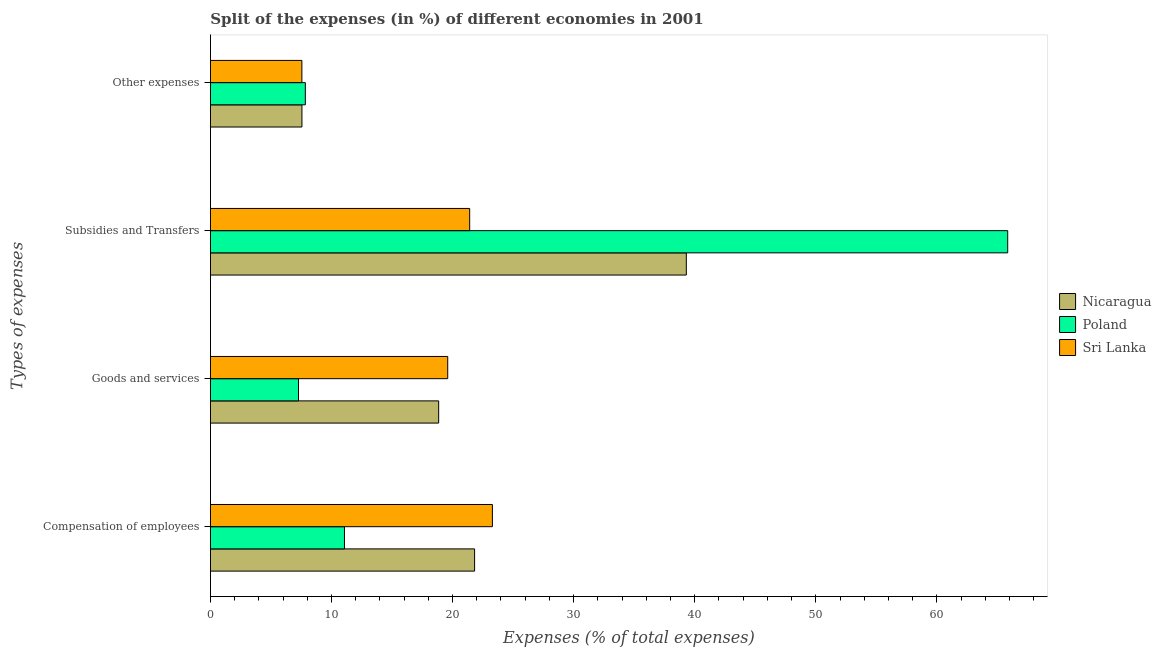How many different coloured bars are there?
Ensure brevity in your answer.  3. How many groups of bars are there?
Your answer should be compact. 4. Are the number of bars on each tick of the Y-axis equal?
Offer a terse response. Yes. What is the label of the 3rd group of bars from the top?
Give a very brief answer. Goods and services. What is the percentage of amount spent on compensation of employees in Nicaragua?
Your response must be concise. 21.82. Across all countries, what is the maximum percentage of amount spent on compensation of employees?
Your answer should be very brief. 23.29. Across all countries, what is the minimum percentage of amount spent on subsidies?
Offer a very short reply. 21.41. In which country was the percentage of amount spent on other expenses minimum?
Your answer should be very brief. Sri Lanka. What is the total percentage of amount spent on subsidies in the graph?
Give a very brief answer. 126.57. What is the difference between the percentage of amount spent on other expenses in Nicaragua and that in Poland?
Offer a terse response. -0.28. What is the difference between the percentage of amount spent on subsidies in Poland and the percentage of amount spent on goods and services in Nicaragua?
Provide a short and direct response. 47. What is the average percentage of amount spent on subsidies per country?
Provide a short and direct response. 42.19. What is the difference between the percentage of amount spent on goods and services and percentage of amount spent on other expenses in Nicaragua?
Keep it short and to the point. 11.29. What is the ratio of the percentage of amount spent on goods and services in Sri Lanka to that in Nicaragua?
Make the answer very short. 1.04. Is the percentage of amount spent on other expenses in Sri Lanka less than that in Nicaragua?
Your response must be concise. Yes. Is the difference between the percentage of amount spent on compensation of employees in Nicaragua and Poland greater than the difference between the percentage of amount spent on subsidies in Nicaragua and Poland?
Provide a short and direct response. Yes. What is the difference between the highest and the second highest percentage of amount spent on goods and services?
Your response must be concise. 0.75. What is the difference between the highest and the lowest percentage of amount spent on goods and services?
Ensure brevity in your answer.  12.32. Is the sum of the percentage of amount spent on subsidies in Sri Lanka and Poland greater than the maximum percentage of amount spent on compensation of employees across all countries?
Your response must be concise. Yes. Is it the case that in every country, the sum of the percentage of amount spent on goods and services and percentage of amount spent on compensation of employees is greater than the sum of percentage of amount spent on subsidies and percentage of amount spent on other expenses?
Your answer should be very brief. No. How many bars are there?
Your answer should be compact. 12. Are all the bars in the graph horizontal?
Provide a succinct answer. Yes. How many countries are there in the graph?
Your response must be concise. 3. Are the values on the major ticks of X-axis written in scientific E-notation?
Your answer should be very brief. No. Does the graph contain any zero values?
Offer a terse response. No. How many legend labels are there?
Ensure brevity in your answer.  3. How are the legend labels stacked?
Your answer should be very brief. Vertical. What is the title of the graph?
Provide a succinct answer. Split of the expenses (in %) of different economies in 2001. Does "Chad" appear as one of the legend labels in the graph?
Ensure brevity in your answer.  No. What is the label or title of the X-axis?
Your response must be concise. Expenses (% of total expenses). What is the label or title of the Y-axis?
Give a very brief answer. Types of expenses. What is the Expenses (% of total expenses) in Nicaragua in Compensation of employees?
Ensure brevity in your answer.  21.82. What is the Expenses (% of total expenses) of Poland in Compensation of employees?
Give a very brief answer. 11.07. What is the Expenses (% of total expenses) of Sri Lanka in Compensation of employees?
Give a very brief answer. 23.29. What is the Expenses (% of total expenses) in Nicaragua in Goods and services?
Provide a succinct answer. 18.85. What is the Expenses (% of total expenses) of Poland in Goods and services?
Make the answer very short. 7.28. What is the Expenses (% of total expenses) of Sri Lanka in Goods and services?
Provide a short and direct response. 19.6. What is the Expenses (% of total expenses) of Nicaragua in Subsidies and Transfers?
Give a very brief answer. 39.31. What is the Expenses (% of total expenses) of Poland in Subsidies and Transfers?
Keep it short and to the point. 65.85. What is the Expenses (% of total expenses) in Sri Lanka in Subsidies and Transfers?
Provide a short and direct response. 21.41. What is the Expenses (% of total expenses) of Nicaragua in Other expenses?
Provide a short and direct response. 7.56. What is the Expenses (% of total expenses) of Poland in Other expenses?
Give a very brief answer. 7.84. What is the Expenses (% of total expenses) in Sri Lanka in Other expenses?
Your answer should be compact. 7.56. Across all Types of expenses, what is the maximum Expenses (% of total expenses) of Nicaragua?
Ensure brevity in your answer.  39.31. Across all Types of expenses, what is the maximum Expenses (% of total expenses) in Poland?
Provide a succinct answer. 65.85. Across all Types of expenses, what is the maximum Expenses (% of total expenses) in Sri Lanka?
Ensure brevity in your answer.  23.29. Across all Types of expenses, what is the minimum Expenses (% of total expenses) in Nicaragua?
Your response must be concise. 7.56. Across all Types of expenses, what is the minimum Expenses (% of total expenses) of Poland?
Your answer should be very brief. 7.28. Across all Types of expenses, what is the minimum Expenses (% of total expenses) in Sri Lanka?
Offer a terse response. 7.56. What is the total Expenses (% of total expenses) of Nicaragua in the graph?
Provide a short and direct response. 87.54. What is the total Expenses (% of total expenses) in Poland in the graph?
Offer a terse response. 92.04. What is the total Expenses (% of total expenses) of Sri Lanka in the graph?
Keep it short and to the point. 71.86. What is the difference between the Expenses (% of total expenses) of Nicaragua in Compensation of employees and that in Goods and services?
Your response must be concise. 2.97. What is the difference between the Expenses (% of total expenses) in Poland in Compensation of employees and that in Goods and services?
Your answer should be very brief. 3.8. What is the difference between the Expenses (% of total expenses) of Sri Lanka in Compensation of employees and that in Goods and services?
Give a very brief answer. 3.69. What is the difference between the Expenses (% of total expenses) of Nicaragua in Compensation of employees and that in Subsidies and Transfers?
Give a very brief answer. -17.49. What is the difference between the Expenses (% of total expenses) in Poland in Compensation of employees and that in Subsidies and Transfers?
Give a very brief answer. -54.78. What is the difference between the Expenses (% of total expenses) of Sri Lanka in Compensation of employees and that in Subsidies and Transfers?
Offer a very short reply. 1.88. What is the difference between the Expenses (% of total expenses) in Nicaragua in Compensation of employees and that in Other expenses?
Ensure brevity in your answer.  14.26. What is the difference between the Expenses (% of total expenses) in Poland in Compensation of employees and that in Other expenses?
Provide a succinct answer. 3.23. What is the difference between the Expenses (% of total expenses) of Sri Lanka in Compensation of employees and that in Other expenses?
Make the answer very short. 15.73. What is the difference between the Expenses (% of total expenses) of Nicaragua in Goods and services and that in Subsidies and Transfers?
Provide a short and direct response. -20.45. What is the difference between the Expenses (% of total expenses) in Poland in Goods and services and that in Subsidies and Transfers?
Provide a succinct answer. -58.57. What is the difference between the Expenses (% of total expenses) of Sri Lanka in Goods and services and that in Subsidies and Transfers?
Ensure brevity in your answer.  -1.81. What is the difference between the Expenses (% of total expenses) of Nicaragua in Goods and services and that in Other expenses?
Your answer should be compact. 11.29. What is the difference between the Expenses (% of total expenses) in Poland in Goods and services and that in Other expenses?
Offer a very short reply. -0.56. What is the difference between the Expenses (% of total expenses) in Sri Lanka in Goods and services and that in Other expenses?
Keep it short and to the point. 12.04. What is the difference between the Expenses (% of total expenses) of Nicaragua in Subsidies and Transfers and that in Other expenses?
Provide a succinct answer. 31.75. What is the difference between the Expenses (% of total expenses) in Poland in Subsidies and Transfers and that in Other expenses?
Keep it short and to the point. 58.01. What is the difference between the Expenses (% of total expenses) in Sri Lanka in Subsidies and Transfers and that in Other expenses?
Make the answer very short. 13.86. What is the difference between the Expenses (% of total expenses) in Nicaragua in Compensation of employees and the Expenses (% of total expenses) in Poland in Goods and services?
Provide a short and direct response. 14.54. What is the difference between the Expenses (% of total expenses) in Nicaragua in Compensation of employees and the Expenses (% of total expenses) in Sri Lanka in Goods and services?
Your answer should be very brief. 2.22. What is the difference between the Expenses (% of total expenses) of Poland in Compensation of employees and the Expenses (% of total expenses) of Sri Lanka in Goods and services?
Your response must be concise. -8.53. What is the difference between the Expenses (% of total expenses) of Nicaragua in Compensation of employees and the Expenses (% of total expenses) of Poland in Subsidies and Transfers?
Offer a very short reply. -44.03. What is the difference between the Expenses (% of total expenses) of Nicaragua in Compensation of employees and the Expenses (% of total expenses) of Sri Lanka in Subsidies and Transfers?
Offer a terse response. 0.41. What is the difference between the Expenses (% of total expenses) in Poland in Compensation of employees and the Expenses (% of total expenses) in Sri Lanka in Subsidies and Transfers?
Ensure brevity in your answer.  -10.34. What is the difference between the Expenses (% of total expenses) in Nicaragua in Compensation of employees and the Expenses (% of total expenses) in Poland in Other expenses?
Your response must be concise. 13.98. What is the difference between the Expenses (% of total expenses) of Nicaragua in Compensation of employees and the Expenses (% of total expenses) of Sri Lanka in Other expenses?
Keep it short and to the point. 14.26. What is the difference between the Expenses (% of total expenses) in Poland in Compensation of employees and the Expenses (% of total expenses) in Sri Lanka in Other expenses?
Ensure brevity in your answer.  3.52. What is the difference between the Expenses (% of total expenses) of Nicaragua in Goods and services and the Expenses (% of total expenses) of Poland in Subsidies and Transfers?
Give a very brief answer. -47. What is the difference between the Expenses (% of total expenses) of Nicaragua in Goods and services and the Expenses (% of total expenses) of Sri Lanka in Subsidies and Transfers?
Give a very brief answer. -2.56. What is the difference between the Expenses (% of total expenses) of Poland in Goods and services and the Expenses (% of total expenses) of Sri Lanka in Subsidies and Transfers?
Your answer should be compact. -14.14. What is the difference between the Expenses (% of total expenses) in Nicaragua in Goods and services and the Expenses (% of total expenses) in Poland in Other expenses?
Keep it short and to the point. 11.01. What is the difference between the Expenses (% of total expenses) of Nicaragua in Goods and services and the Expenses (% of total expenses) of Sri Lanka in Other expenses?
Keep it short and to the point. 11.3. What is the difference between the Expenses (% of total expenses) in Poland in Goods and services and the Expenses (% of total expenses) in Sri Lanka in Other expenses?
Provide a short and direct response. -0.28. What is the difference between the Expenses (% of total expenses) in Nicaragua in Subsidies and Transfers and the Expenses (% of total expenses) in Poland in Other expenses?
Your answer should be very brief. 31.47. What is the difference between the Expenses (% of total expenses) of Nicaragua in Subsidies and Transfers and the Expenses (% of total expenses) of Sri Lanka in Other expenses?
Ensure brevity in your answer.  31.75. What is the difference between the Expenses (% of total expenses) in Poland in Subsidies and Transfers and the Expenses (% of total expenses) in Sri Lanka in Other expenses?
Make the answer very short. 58.29. What is the average Expenses (% of total expenses) in Nicaragua per Types of expenses?
Your response must be concise. 21.89. What is the average Expenses (% of total expenses) in Poland per Types of expenses?
Keep it short and to the point. 23.01. What is the average Expenses (% of total expenses) in Sri Lanka per Types of expenses?
Your response must be concise. 17.97. What is the difference between the Expenses (% of total expenses) in Nicaragua and Expenses (% of total expenses) in Poland in Compensation of employees?
Ensure brevity in your answer.  10.75. What is the difference between the Expenses (% of total expenses) in Nicaragua and Expenses (% of total expenses) in Sri Lanka in Compensation of employees?
Your answer should be very brief. -1.47. What is the difference between the Expenses (% of total expenses) in Poland and Expenses (% of total expenses) in Sri Lanka in Compensation of employees?
Provide a short and direct response. -12.22. What is the difference between the Expenses (% of total expenses) of Nicaragua and Expenses (% of total expenses) of Poland in Goods and services?
Provide a succinct answer. 11.58. What is the difference between the Expenses (% of total expenses) of Nicaragua and Expenses (% of total expenses) of Sri Lanka in Goods and services?
Offer a very short reply. -0.75. What is the difference between the Expenses (% of total expenses) of Poland and Expenses (% of total expenses) of Sri Lanka in Goods and services?
Provide a short and direct response. -12.32. What is the difference between the Expenses (% of total expenses) of Nicaragua and Expenses (% of total expenses) of Poland in Subsidies and Transfers?
Provide a succinct answer. -26.54. What is the difference between the Expenses (% of total expenses) in Nicaragua and Expenses (% of total expenses) in Sri Lanka in Subsidies and Transfers?
Provide a succinct answer. 17.89. What is the difference between the Expenses (% of total expenses) of Poland and Expenses (% of total expenses) of Sri Lanka in Subsidies and Transfers?
Provide a succinct answer. 44.44. What is the difference between the Expenses (% of total expenses) in Nicaragua and Expenses (% of total expenses) in Poland in Other expenses?
Your answer should be very brief. -0.28. What is the difference between the Expenses (% of total expenses) of Nicaragua and Expenses (% of total expenses) of Sri Lanka in Other expenses?
Offer a terse response. 0.01. What is the difference between the Expenses (% of total expenses) of Poland and Expenses (% of total expenses) of Sri Lanka in Other expenses?
Your answer should be compact. 0.28. What is the ratio of the Expenses (% of total expenses) in Nicaragua in Compensation of employees to that in Goods and services?
Offer a terse response. 1.16. What is the ratio of the Expenses (% of total expenses) of Poland in Compensation of employees to that in Goods and services?
Provide a succinct answer. 1.52. What is the ratio of the Expenses (% of total expenses) of Sri Lanka in Compensation of employees to that in Goods and services?
Your answer should be compact. 1.19. What is the ratio of the Expenses (% of total expenses) of Nicaragua in Compensation of employees to that in Subsidies and Transfers?
Offer a terse response. 0.56. What is the ratio of the Expenses (% of total expenses) of Poland in Compensation of employees to that in Subsidies and Transfers?
Provide a succinct answer. 0.17. What is the ratio of the Expenses (% of total expenses) of Sri Lanka in Compensation of employees to that in Subsidies and Transfers?
Offer a very short reply. 1.09. What is the ratio of the Expenses (% of total expenses) in Nicaragua in Compensation of employees to that in Other expenses?
Give a very brief answer. 2.89. What is the ratio of the Expenses (% of total expenses) of Poland in Compensation of employees to that in Other expenses?
Keep it short and to the point. 1.41. What is the ratio of the Expenses (% of total expenses) of Sri Lanka in Compensation of employees to that in Other expenses?
Make the answer very short. 3.08. What is the ratio of the Expenses (% of total expenses) in Nicaragua in Goods and services to that in Subsidies and Transfers?
Keep it short and to the point. 0.48. What is the ratio of the Expenses (% of total expenses) in Poland in Goods and services to that in Subsidies and Transfers?
Give a very brief answer. 0.11. What is the ratio of the Expenses (% of total expenses) of Sri Lanka in Goods and services to that in Subsidies and Transfers?
Make the answer very short. 0.92. What is the ratio of the Expenses (% of total expenses) of Nicaragua in Goods and services to that in Other expenses?
Your answer should be very brief. 2.49. What is the ratio of the Expenses (% of total expenses) in Poland in Goods and services to that in Other expenses?
Your response must be concise. 0.93. What is the ratio of the Expenses (% of total expenses) of Sri Lanka in Goods and services to that in Other expenses?
Offer a terse response. 2.59. What is the ratio of the Expenses (% of total expenses) of Nicaragua in Subsidies and Transfers to that in Other expenses?
Offer a terse response. 5.2. What is the ratio of the Expenses (% of total expenses) in Poland in Subsidies and Transfers to that in Other expenses?
Make the answer very short. 8.4. What is the ratio of the Expenses (% of total expenses) in Sri Lanka in Subsidies and Transfers to that in Other expenses?
Make the answer very short. 2.83. What is the difference between the highest and the second highest Expenses (% of total expenses) in Nicaragua?
Your answer should be compact. 17.49. What is the difference between the highest and the second highest Expenses (% of total expenses) of Poland?
Provide a succinct answer. 54.78. What is the difference between the highest and the second highest Expenses (% of total expenses) of Sri Lanka?
Offer a terse response. 1.88. What is the difference between the highest and the lowest Expenses (% of total expenses) in Nicaragua?
Provide a short and direct response. 31.75. What is the difference between the highest and the lowest Expenses (% of total expenses) in Poland?
Keep it short and to the point. 58.57. What is the difference between the highest and the lowest Expenses (% of total expenses) of Sri Lanka?
Offer a terse response. 15.73. 